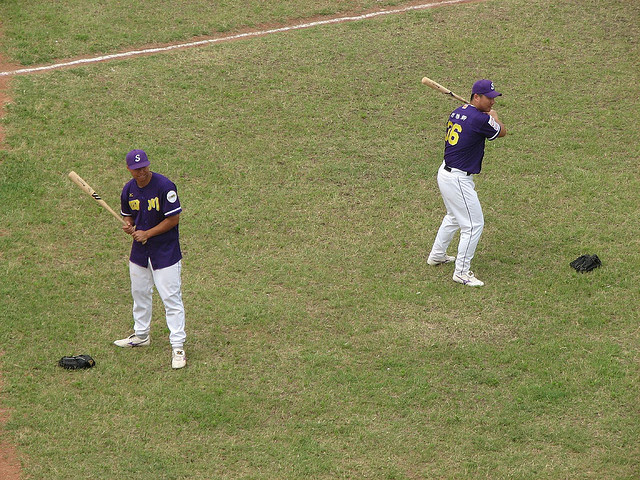Please extract the text content from this image. 36 M S 